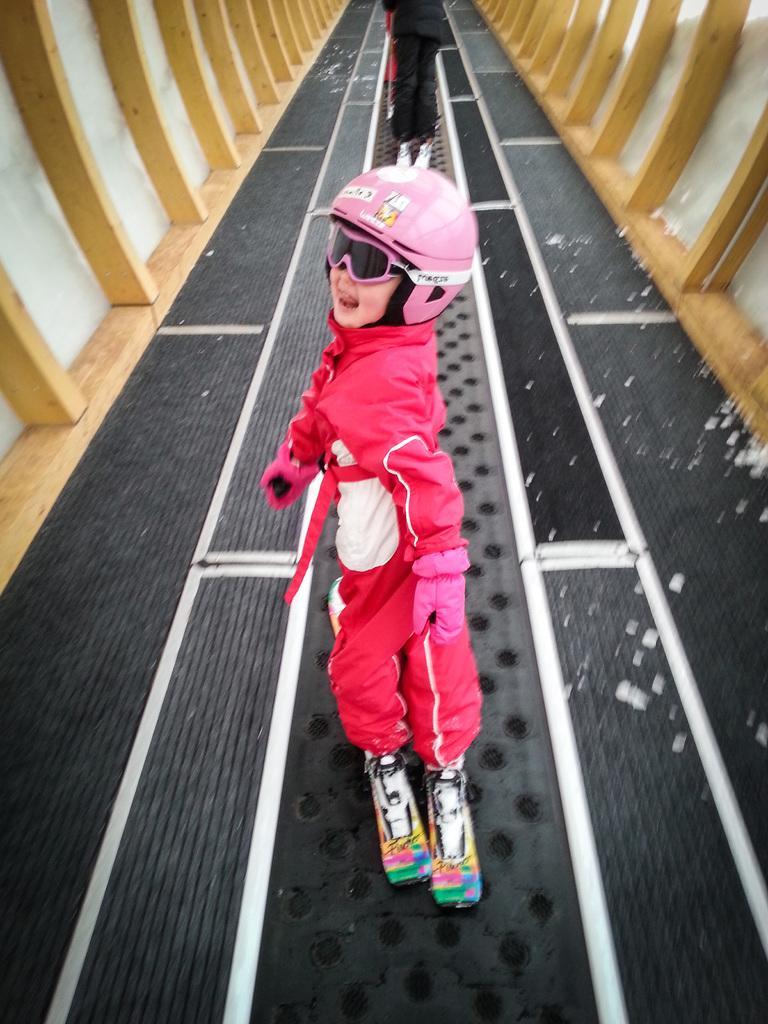Please provide a concise description of this image. In this image there are two people skating in between the wooden walls, there are white color pieces on the floor. 